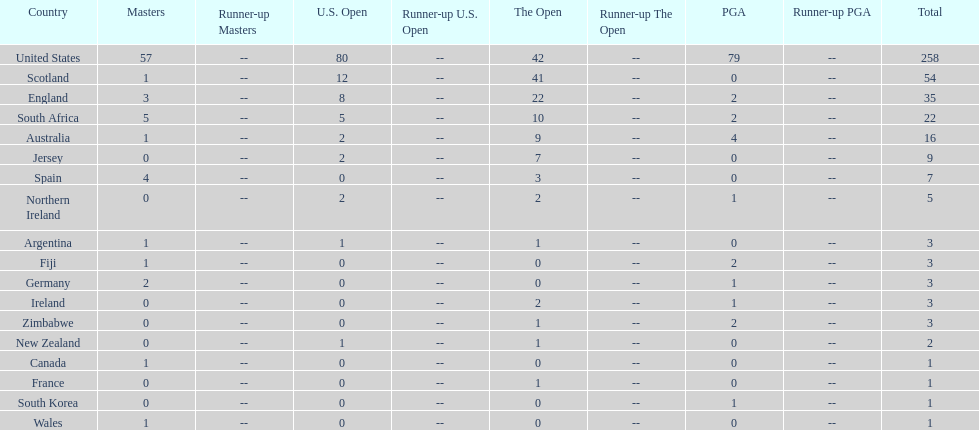How many u.s. open successes does fiji have? 0. 